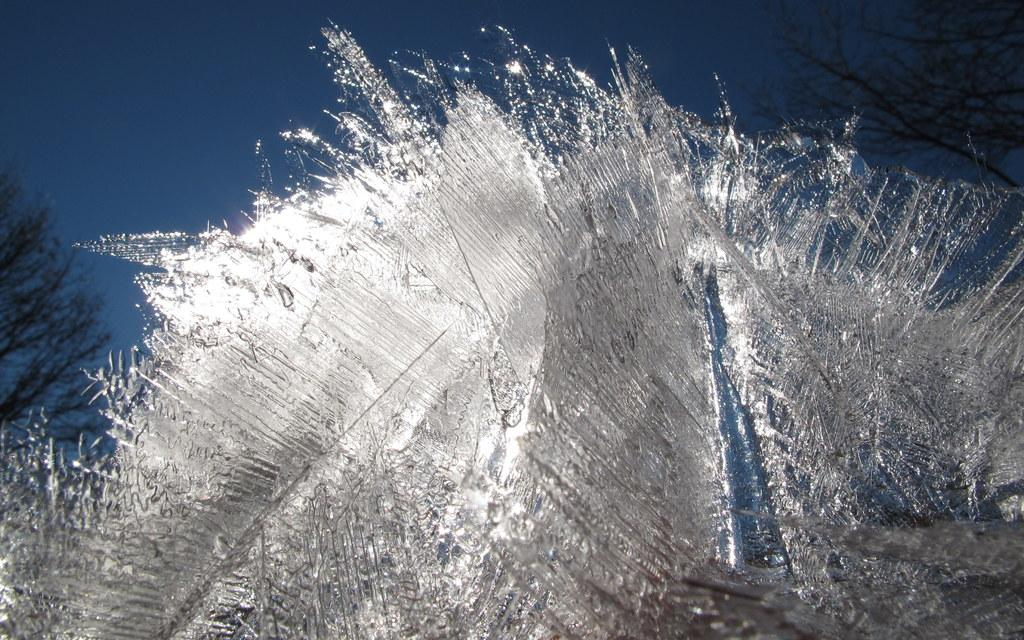What type of vegetation can be seen on both sides of the image? There are trees on the right side and the left side of the image. What is present in the front of the image? It appears to be ice in the front of the image. What is visible at the top of the image? The sky is visible at the top of the image. Can you tell me how many cacti are present in the image? There are no cacti present in the image; it features trees on both sides. What color is the thread used to sew the ice in the image? There is no thread present in the image, as it features ice in the front. 